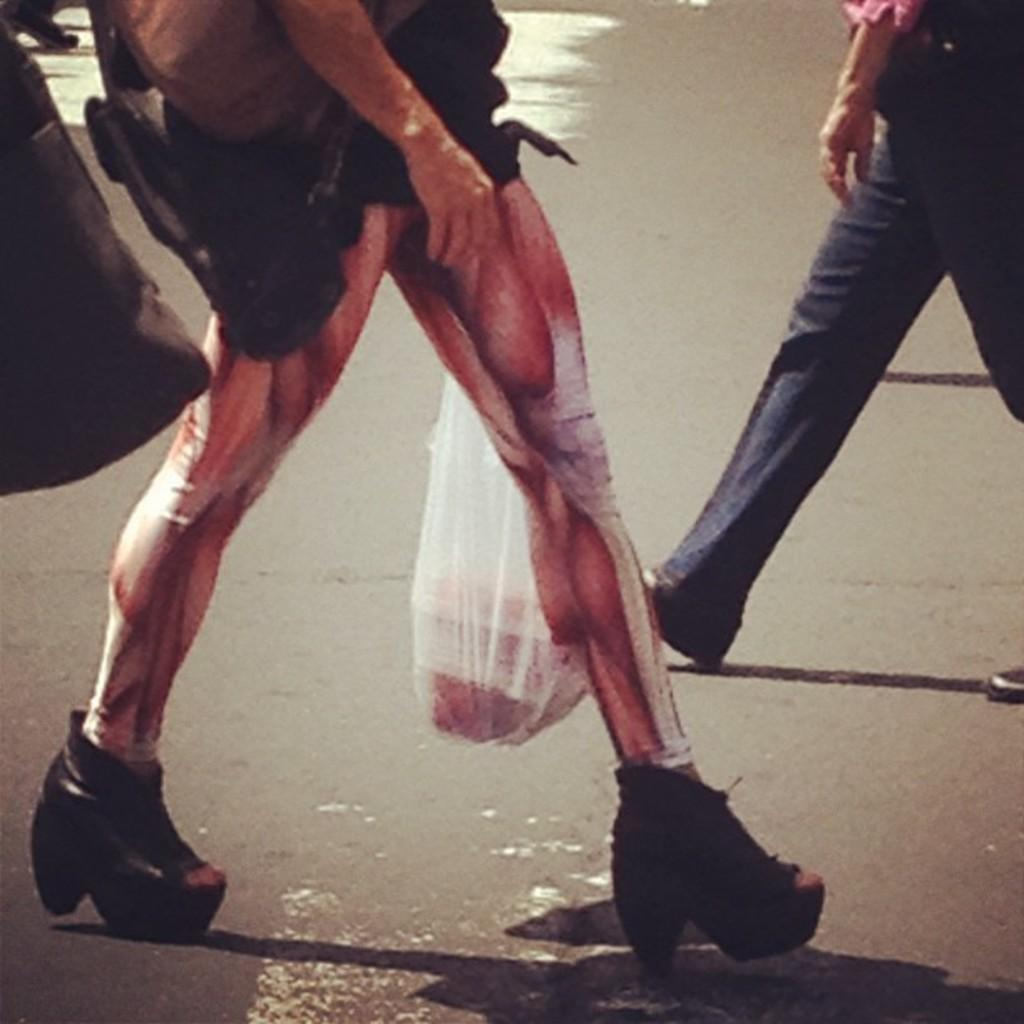Who is the main subject in the image? There is a man in the center of the image. What type of kettle is the man holding in the image? There is no kettle present in the image; the man is the only subject mentioned in the provided fact. 